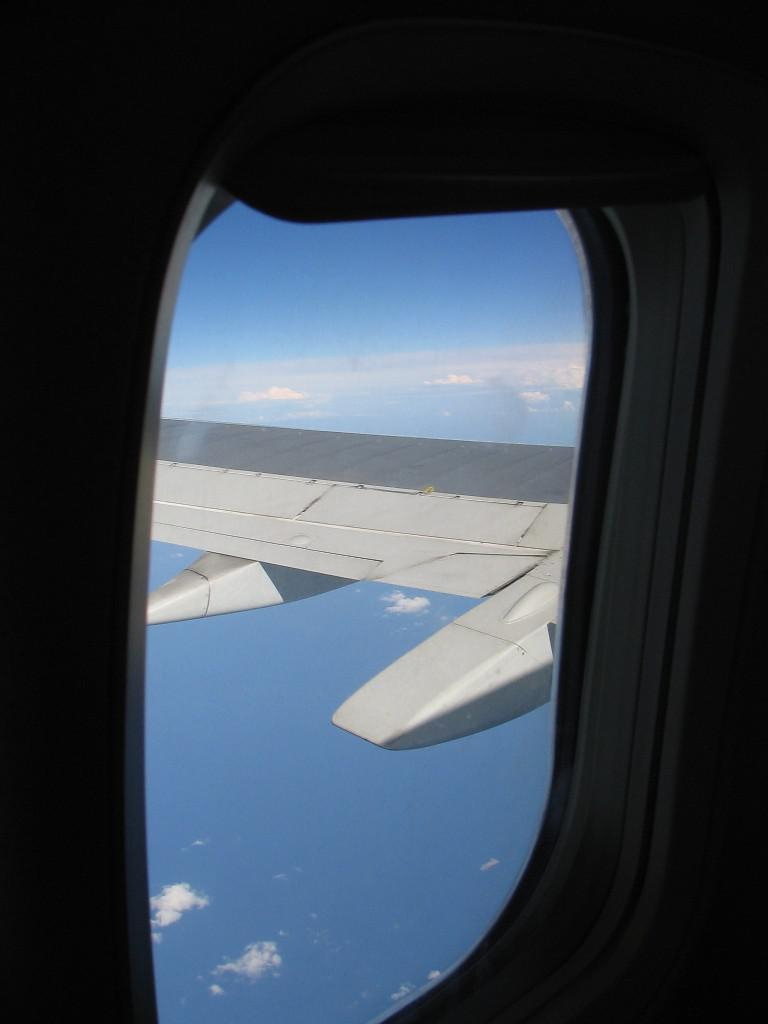What type of view is shown in the image? The image shows the window of a flight. What can be seen through the window? The wing of the flight is visible through the window. What is visible outside the window? There is sky visible in the image. What can be observed in the sky? Clouds are present in the sky. Can you tell me how many friends are sitting next to the tin in the image? There is no tin or friends present in the image; it shows the window of a flight with the wing and sky visible. 